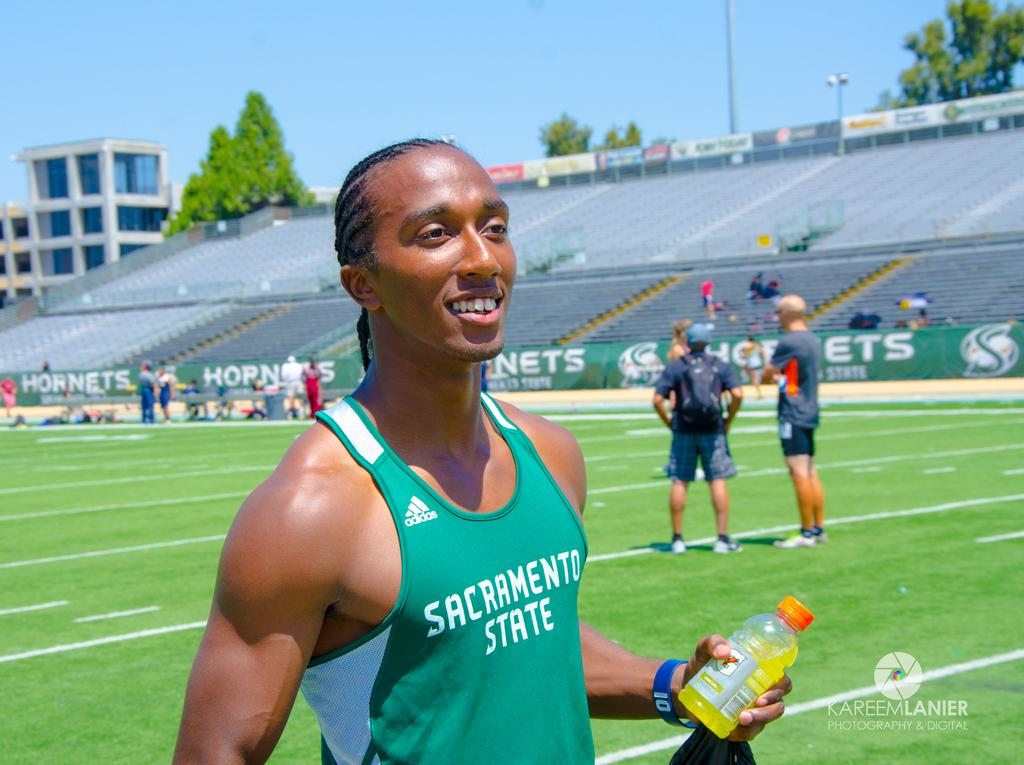What is the man in the image doing? The man is standing on the ground and holding a bottle. Can you describe the setting in which the man is located? The man is in a stadium ground. Are there any other people present in the image? Yes, there are people standing in the stadium ground. What type of calculator is the man using in the image? There is no calculator present in the image. How many times does the man sneeze in the image? There is no indication of the man sneezing in the image. 